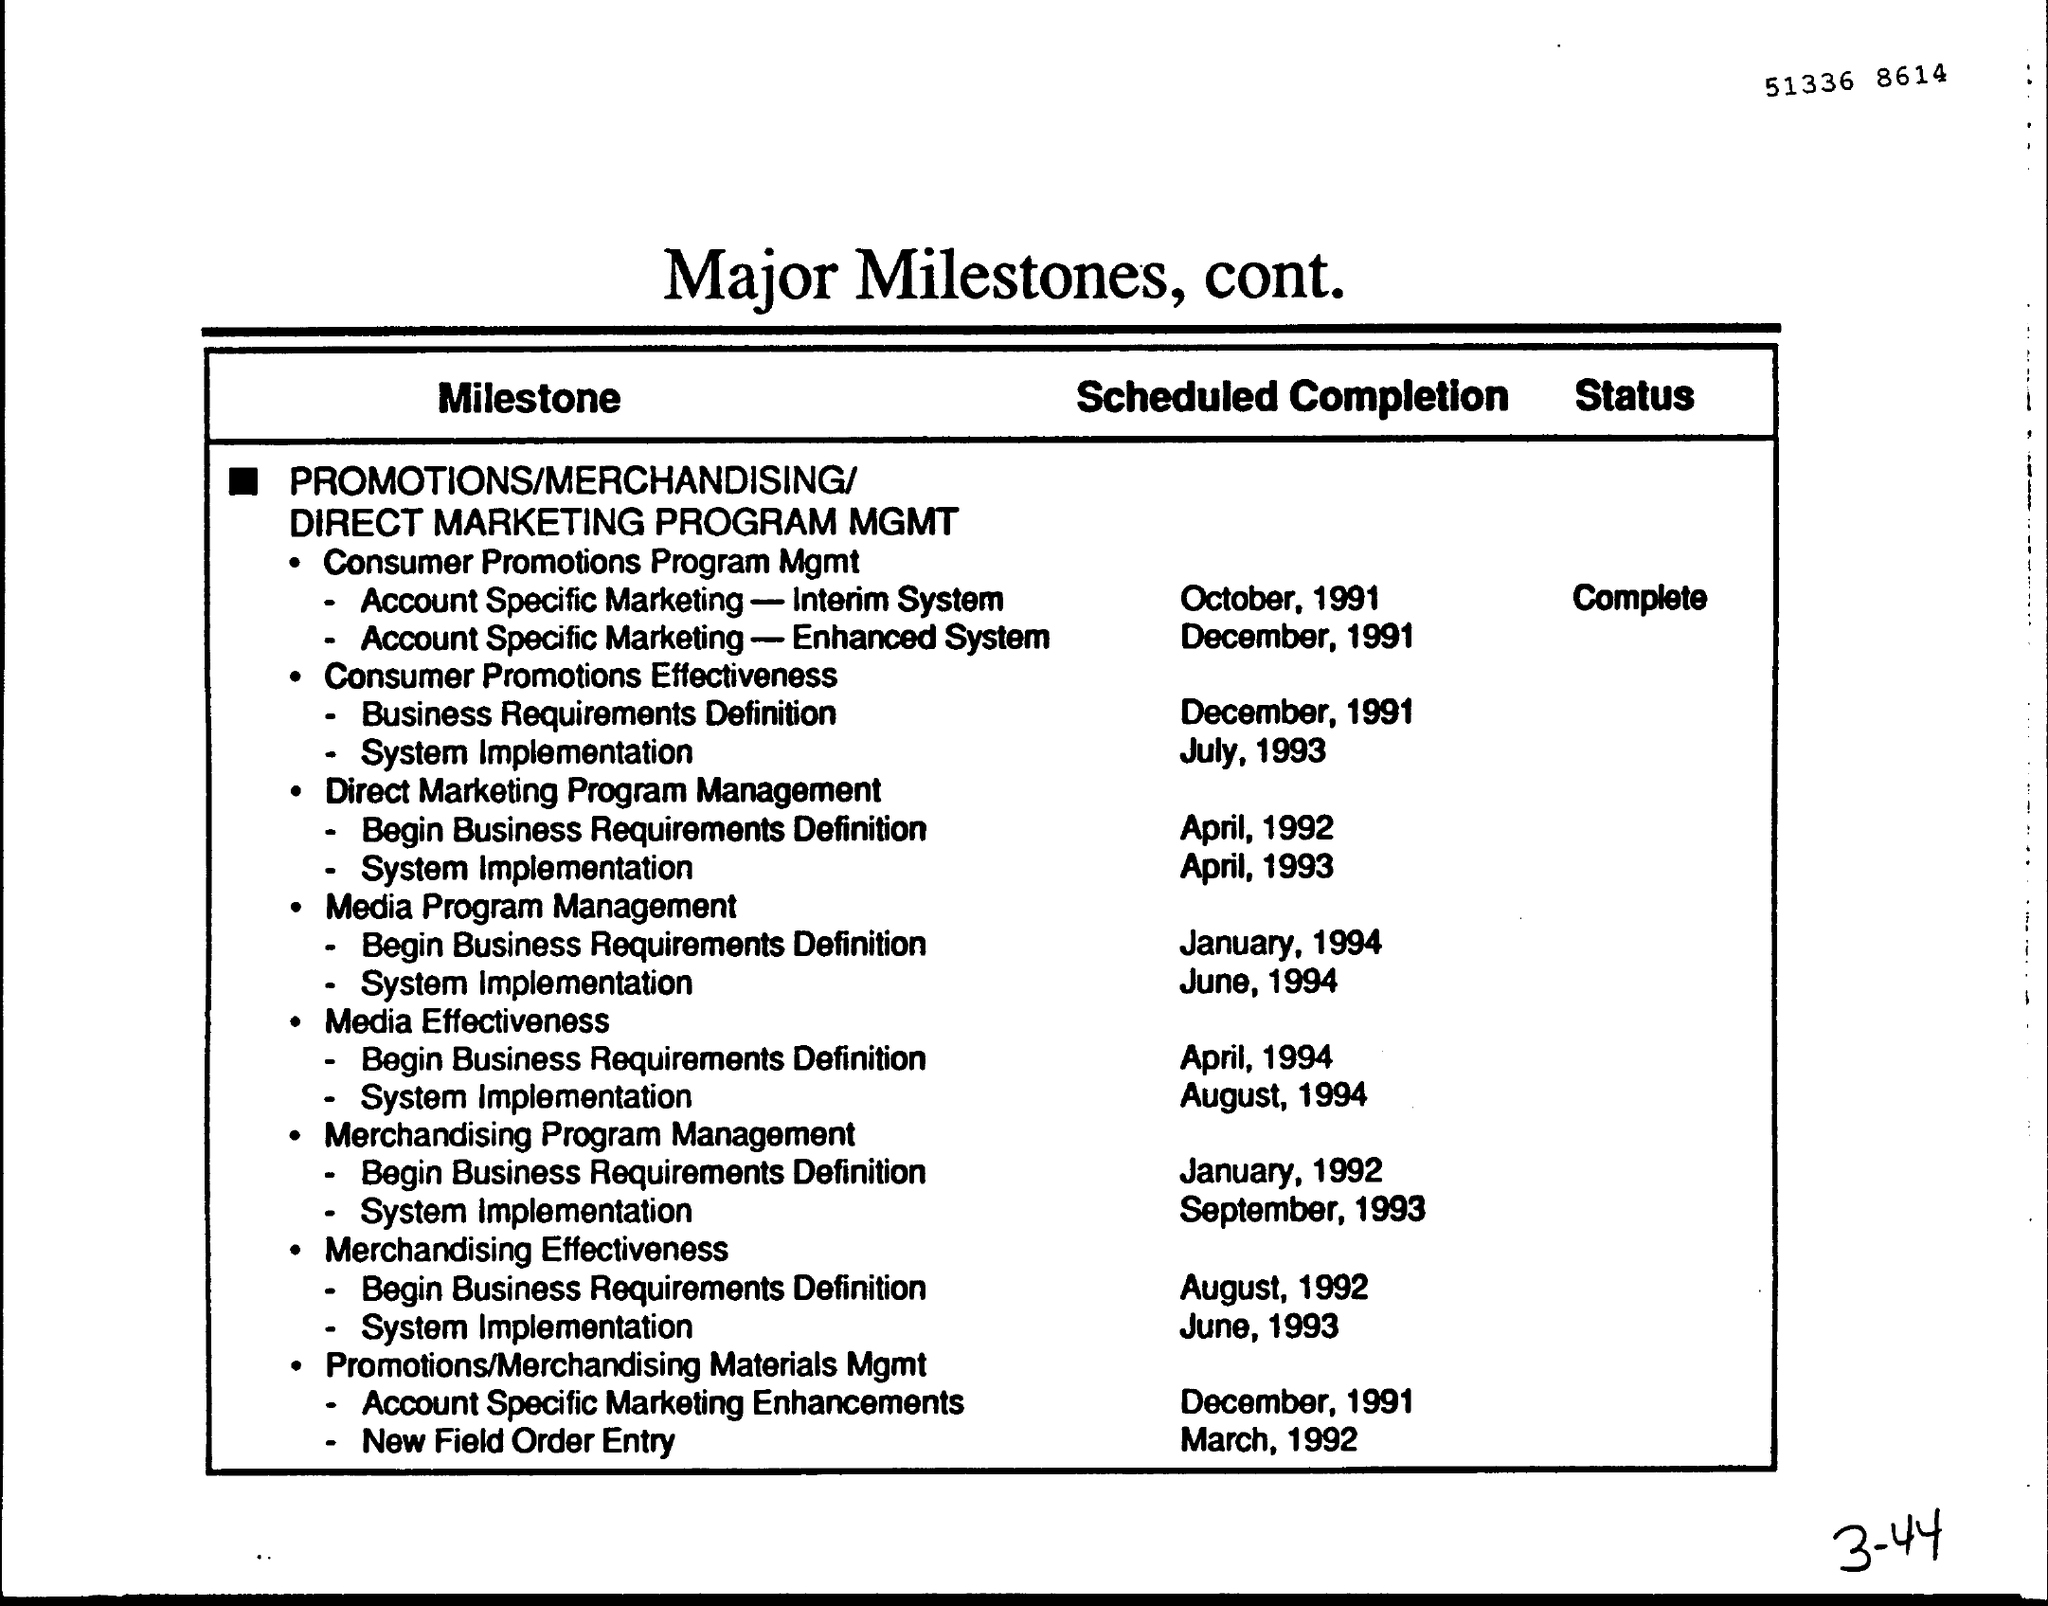What is written in the Letter Head ?
Give a very brief answer. Major Milestones, cont. 